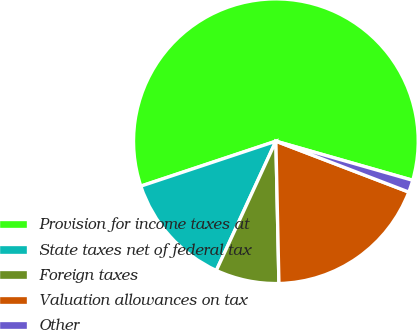Convert chart. <chart><loc_0><loc_0><loc_500><loc_500><pie_chart><fcel>Provision for income taxes at<fcel>State taxes net of federal tax<fcel>Foreign taxes<fcel>Valuation allowances on tax<fcel>Other<nl><fcel>59.54%<fcel>13.02%<fcel>7.21%<fcel>18.84%<fcel>1.39%<nl></chart> 